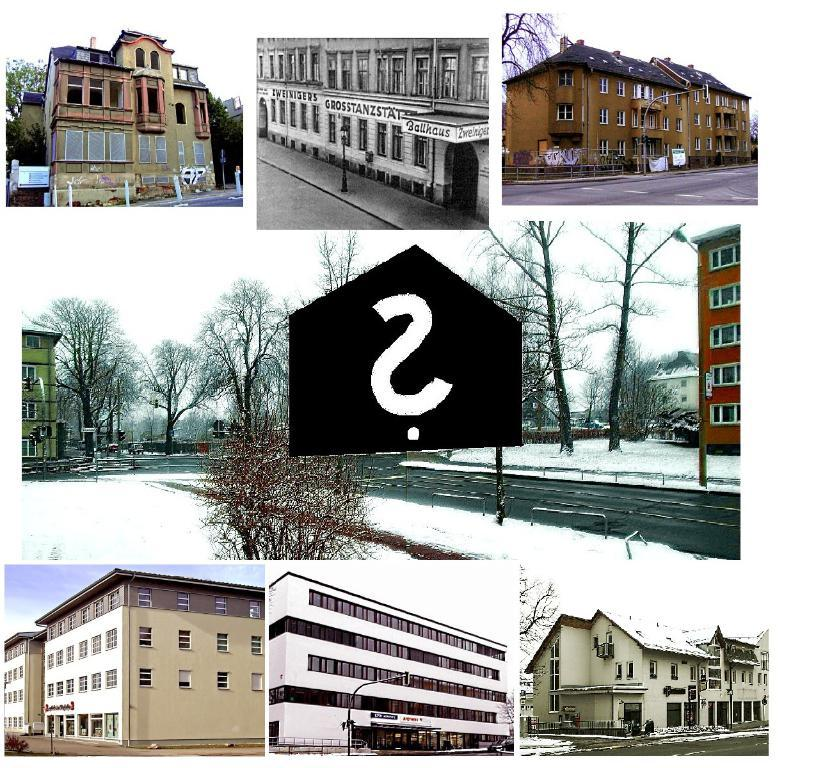What type of image is being described? The image is a collage of different pictures. What kind of structures can be seen in the collage? There are pictures of buildings in the collage. What type of natural elements are present in the collage? There are pictures of trees in the collage. What type of locket is hanging from the tree in the image? There is no locket present in the image; it is a collage of pictures of buildings and trees. 